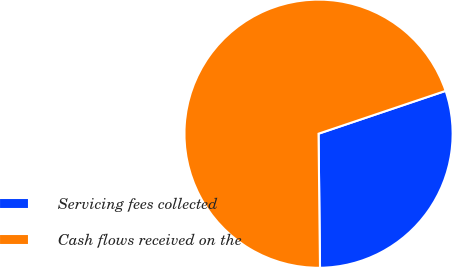Convert chart. <chart><loc_0><loc_0><loc_500><loc_500><pie_chart><fcel>Servicing fees collected<fcel>Cash flows received on the<nl><fcel>30.0%<fcel>70.0%<nl></chart> 